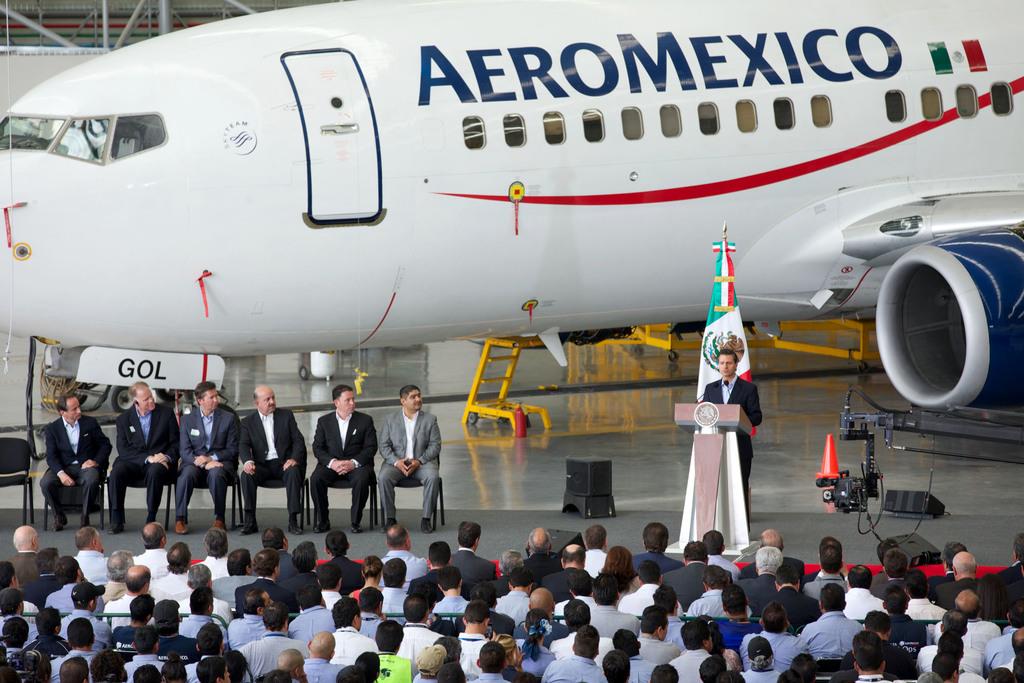What country is the airlines of the plane from?
Make the answer very short. Mexico. 